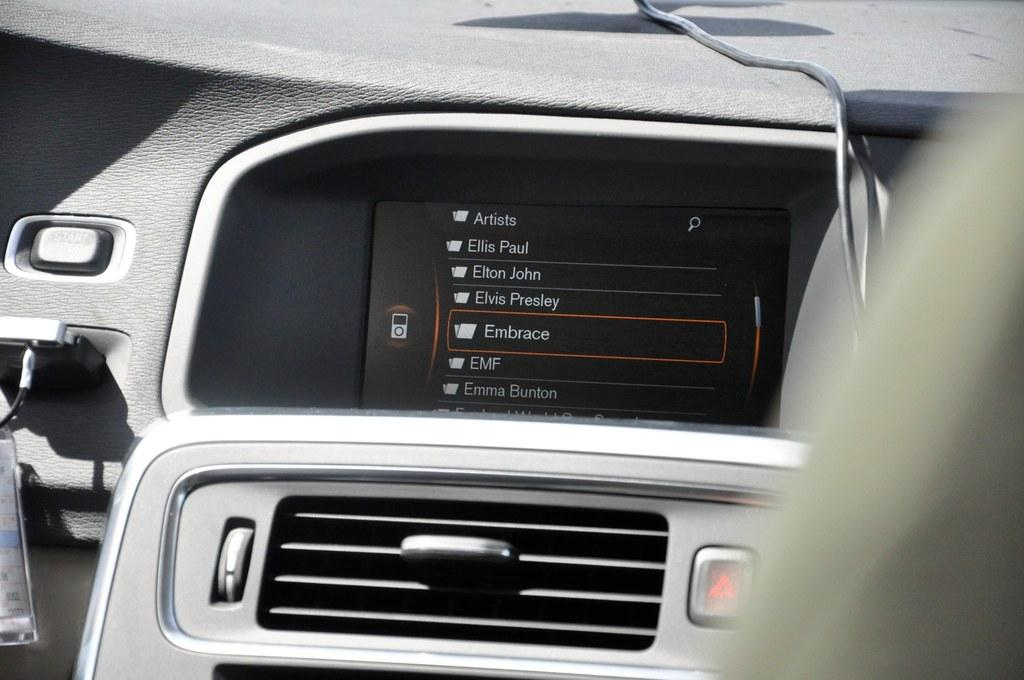What is the main object in the image? There is a screen in the image. What can be found on the screen? Text and icons are visible on the screen. What other elements are present in the image? There are buttons, wires, and objects in the image. How would you describe the right side of the image? The right side of the image has a blurred view. Where is the map located in the image? There is no map present in the image. What type of cake is shown on the screen? There is no cake present in the image. 